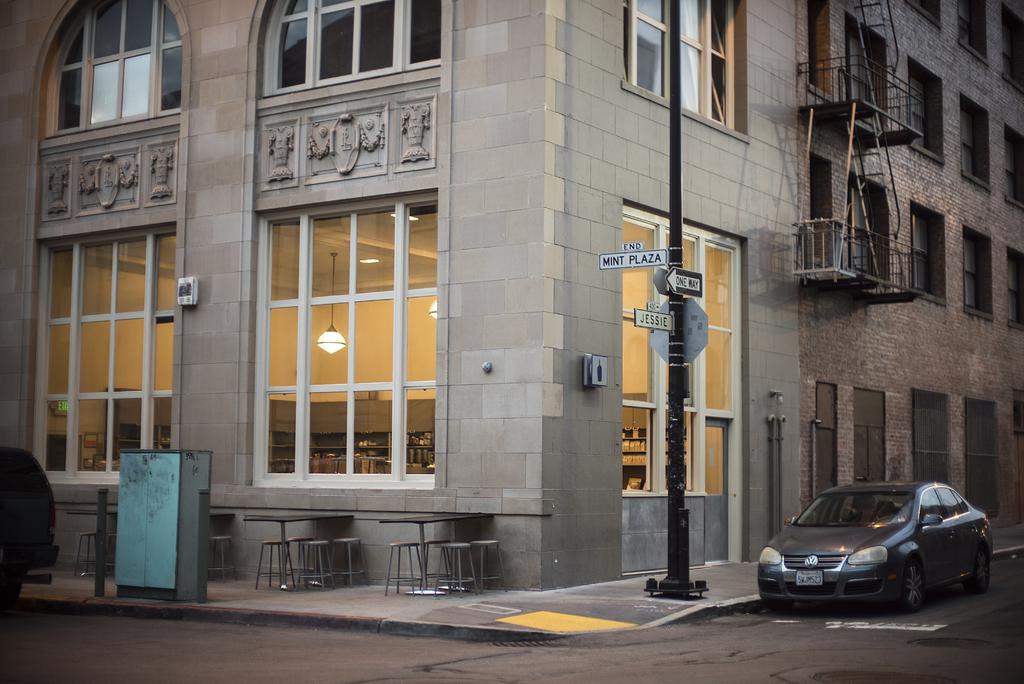What type of structure is visible in the image? There is a building in the image. What feature can be seen on the building? The building has windows. What other objects are present in the image? There is a pole, a board, stools, a table, a road, and a vehicle in the image. What is the vehicle's identification number? The vehicle has a number plate. What type of beginner's course is being offered on the board in the image? There is no indication of a course or any text on the board in the image. Is the vehicle in the image covered by insurance? There is no information about the vehicle's insurance in the image. 